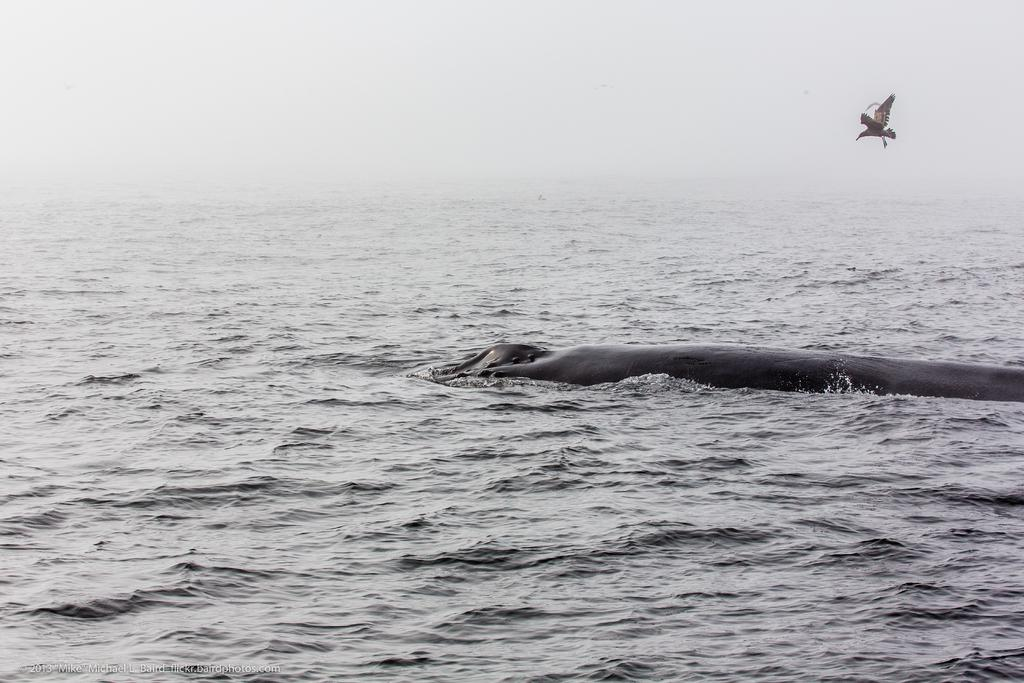What type of animal can be seen on the right side of the image? There is a bird on the right side of the image. What is visible at the bottom of the image? Water is visible at the bottom of the image. What type of bread is the bird eating in the image? There is no bread present in the image, and the bird is not shown eating anything. 